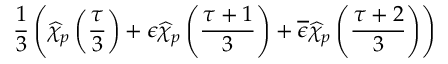<formula> <loc_0><loc_0><loc_500><loc_500>\frac { 1 } { 3 } \left ( \widehat { \chi } _ { p } \left ( \frac { \tau } { 3 } \right ) + \epsilon \widehat { \chi } _ { p } \left ( \frac { \tau + 1 } { 3 } \right ) + \overline { \epsilon } \widehat { \chi } _ { p } \left ( \frac { \tau + 2 } { 3 } \right ) \right )</formula> 